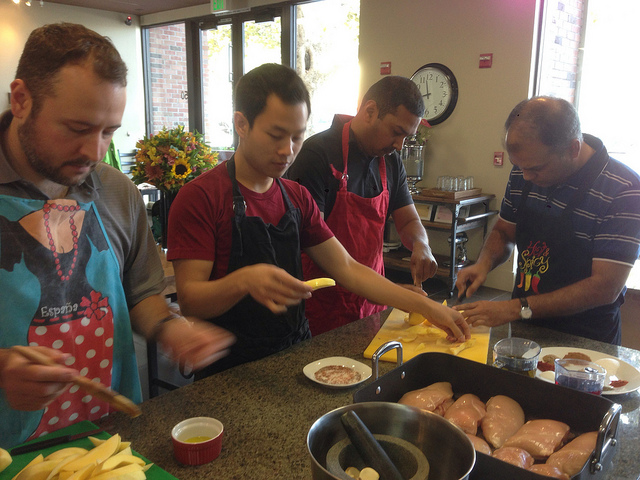Can you describe what each person is doing? Sure, starting from the left, the first person is slicing potatoes, the second one is rolling dough with a rolling pin, the third appears to be seasoning or marinating chicken, and the fourth is actively engaged in chopping either vegetables or herbs. Do they seem experienced in cooking? They appear to be quite focused and handling their tasks proficiently, which suggests they have some experience in cooking, although the presence of others and the setting might indicate they are still learning or enjoying a collaborative cooking experience. 